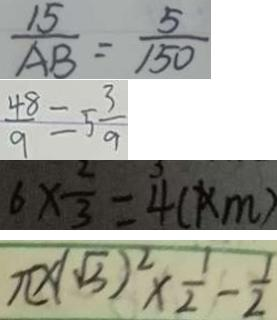Convert formula to latex. <formula><loc_0><loc_0><loc_500><loc_500>\frac { 1 5 } { A B } = \frac { 5 } { 1 5 0 } 
 \frac { 4 8 } { 9 } = 5 \frac { 3 } { 9 } 
 6 \times \frac { 2 } { 3 } = 4 ( k m ) 
 \pi \times ( \sqrt { 3 } ) ^ { 2 } \times \frac { 1 } { 2 } - \frac { 1 } { 2 }</formula> 